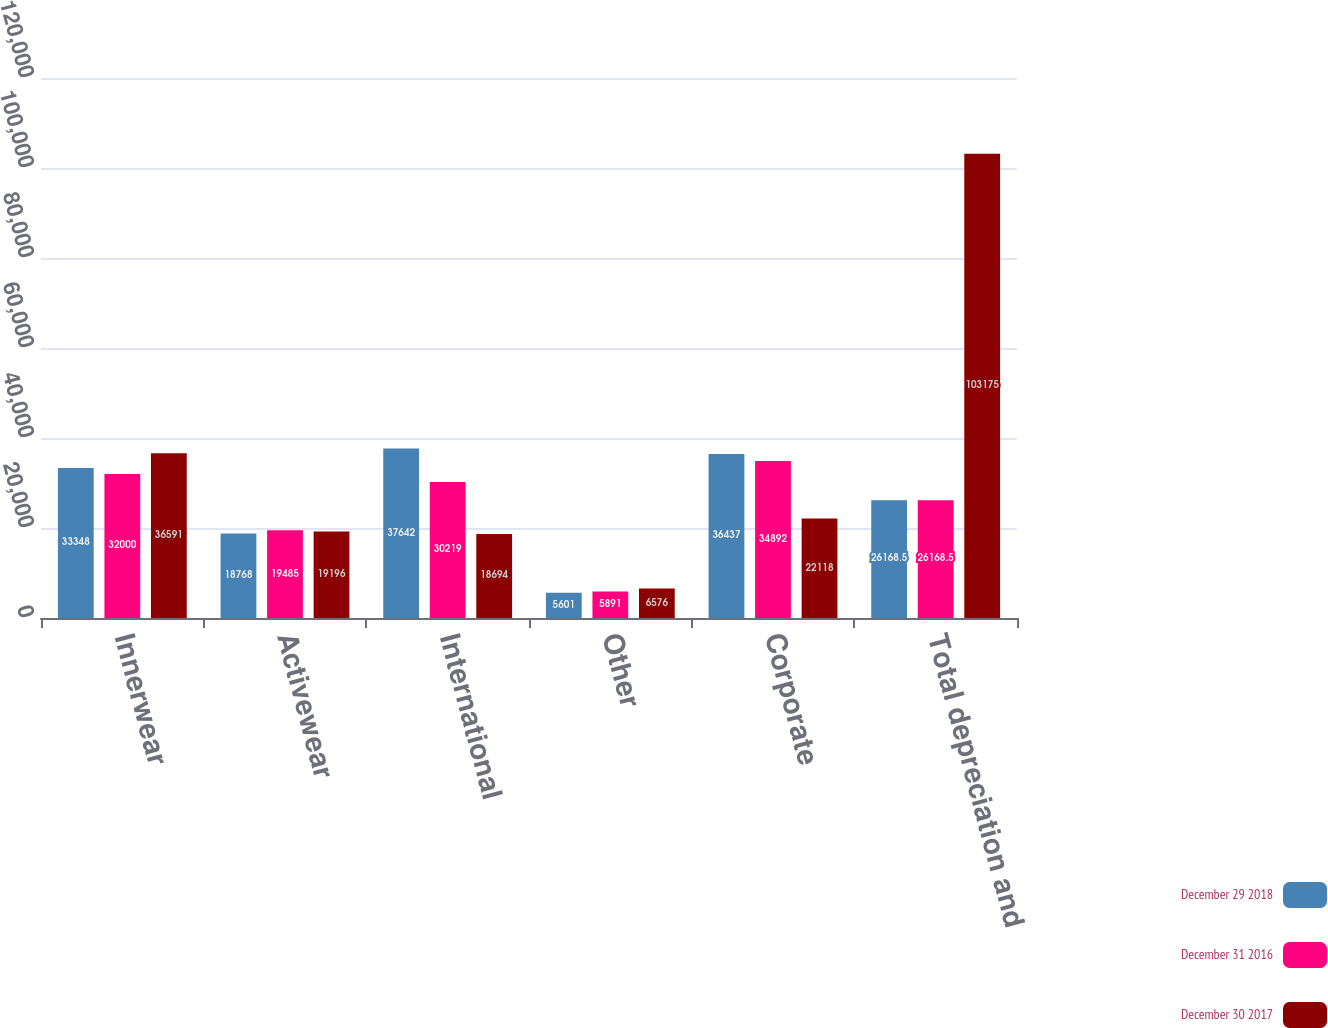<chart> <loc_0><loc_0><loc_500><loc_500><stacked_bar_chart><ecel><fcel>Innerwear<fcel>Activewear<fcel>International<fcel>Other<fcel>Corporate<fcel>Total depreciation and<nl><fcel>December 29 2018<fcel>33348<fcel>18768<fcel>37642<fcel>5601<fcel>36437<fcel>26168.5<nl><fcel>December 31 2016<fcel>32000<fcel>19485<fcel>30219<fcel>5891<fcel>34892<fcel>26168.5<nl><fcel>December 30 2017<fcel>36591<fcel>19196<fcel>18694<fcel>6576<fcel>22118<fcel>103175<nl></chart> 